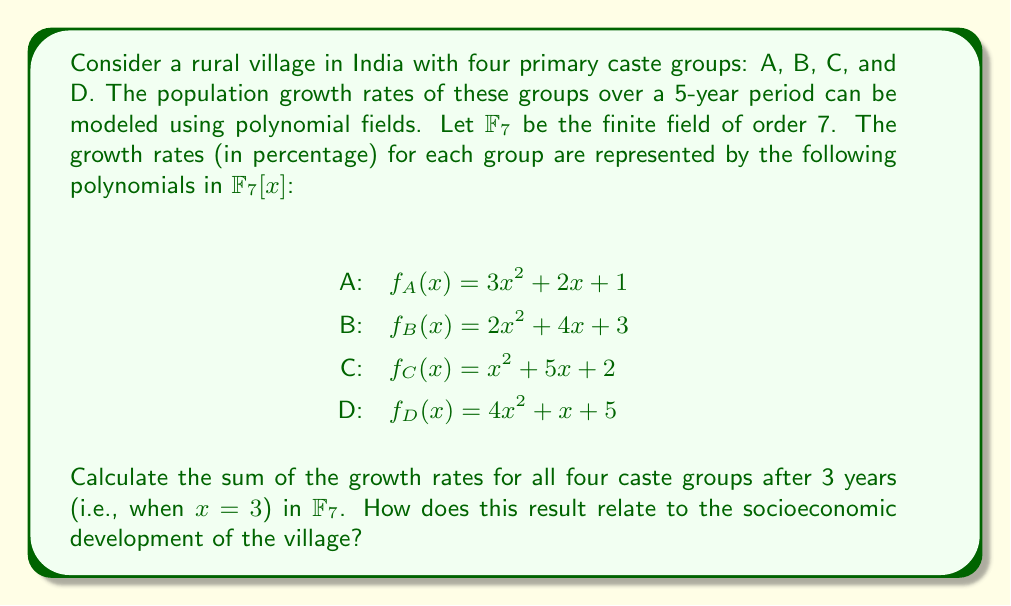Solve this math problem. To solve this problem, we need to follow these steps:

1) Evaluate each polynomial at $x = 3$ in $\mathbb{F}_7$:

   For group A: 
   $f_A(3) = 3(3^2) + 2(3) + 1 = 3(2) + 6 + 1 = 6 + 6 + 1 = 13 \equiv 6 \pmod{7}$

   For group B:
   $f_B(3) = 2(3^2) + 4(3) + 3 = 2(2) + 12 + 3 = 4 + 5 + 3 = 12 \equiv 5 \pmod{7}$

   For group C:
   $f_C(3) = 3^2 + 5(3) + 2 = 2 + 15 + 2 = 19 \equiv 5 \pmod{7}$

   For group D:
   $f_D(3) = 4(3^2) + 3 + 5 = 4(2) + 3 + 5 = 8 + 3 + 5 = 16 \equiv 2 \pmod{7}$

2) Sum the results in $\mathbb{F}_7$:
   $6 + 5 + 5 + 2 = 18 \equiv 4 \pmod{7}$

3) Interpretation: The sum of growth rates being 4 (mod 7) indicates a moderate overall growth. In the context of socioeconomic development, this suggests that the village is experiencing some progress, but it's not uniform across all caste groups. The varying growth rates (6, 5, 5, and 2) imply potential disparities in development among different castes, which could be a focus area for targeted interventions to ensure more equitable growth.
Answer: $4 \pmod{7}$ 